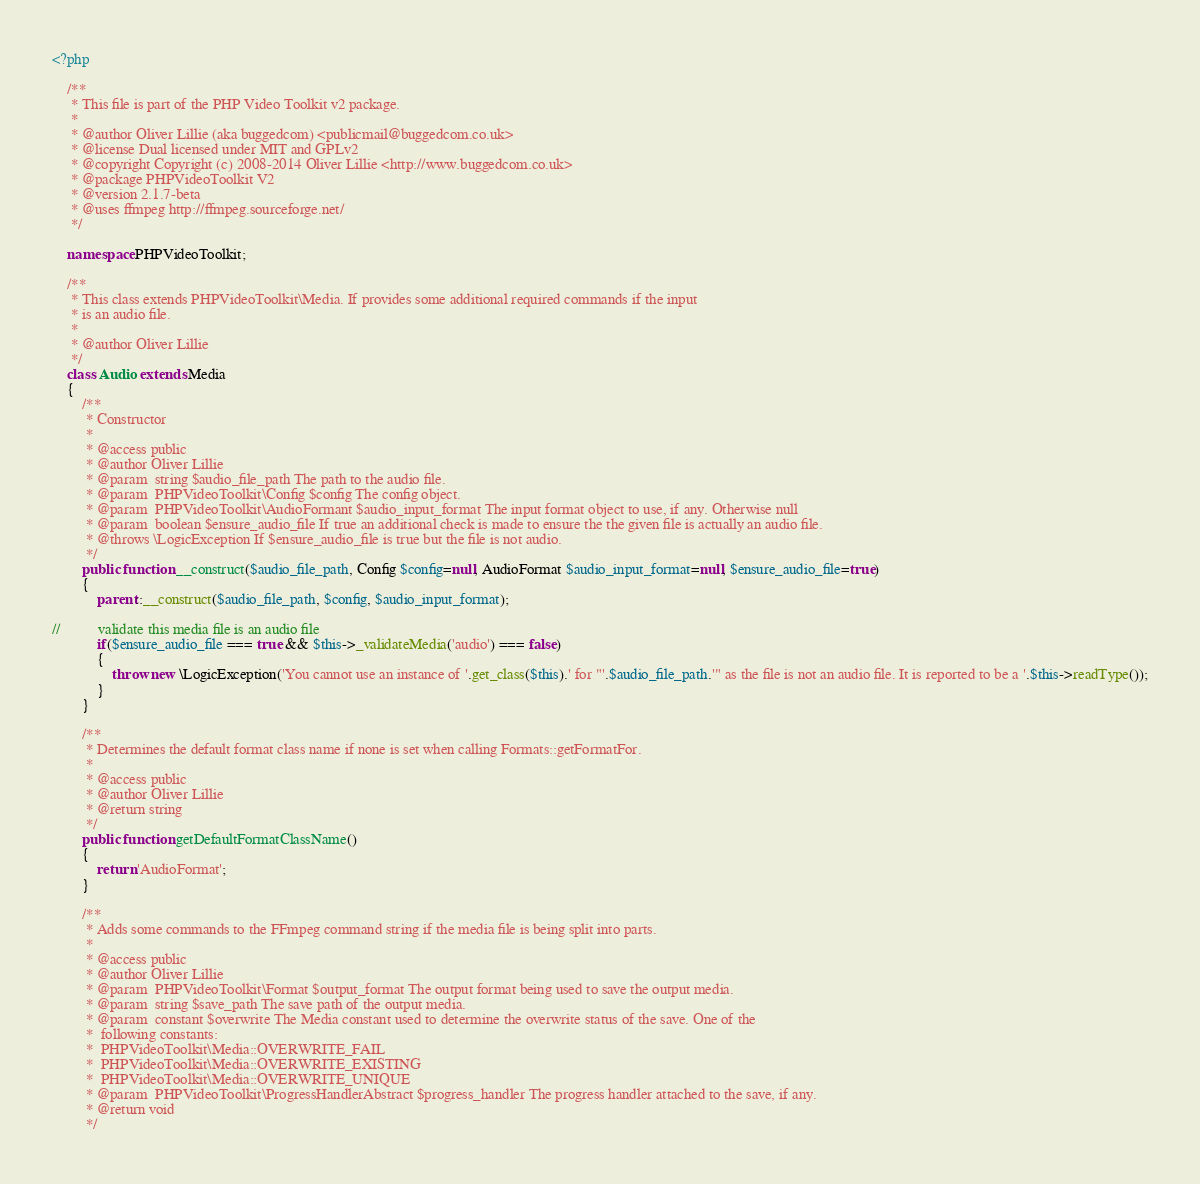Convert code to text. <code><loc_0><loc_0><loc_500><loc_500><_PHP_><?php
    
    /**
     * This file is part of the PHP Video Toolkit v2 package.
     *
     * @author Oliver Lillie (aka buggedcom) <publicmail@buggedcom.co.uk>
     * @license Dual licensed under MIT and GPLv2
     * @copyright Copyright (c) 2008-2014 Oliver Lillie <http://www.buggedcom.co.uk>
     * @package PHPVideoToolkit V2
     * @version 2.1.7-beta
     * @uses ffmpeg http://ffmpeg.sourceforge.net/
     */
     
    namespace PHPVideoToolkit;

    /**
     * This class extends PHPVideoToolkit\Media. If provides some additional required commands if the input
     * is an audio file.
     *
     * @author Oliver Lillie
     */
    class Audio extends Media
    {
        /**
         * Constructor
         *
         * @access public
         * @author Oliver Lillie
         * @param  string $audio_file_path The path to the audio file.
         * @param  PHPVideoToolkit\Config $config The config object.
         * @param  PHPVideoToolkit\AudioFormant $audio_input_format The input format object to use, if any. Otherwise null
         * @param  boolean $ensure_audio_file If true an additional check is made to ensure the the given file is actually an audio file.
         * @throws \LogicException If $ensure_audio_file is true but the file is not audio.
         */
        public function __construct($audio_file_path, Config $config=null, AudioFormat $audio_input_format=null, $ensure_audio_file=true)
        {
            parent::__construct($audio_file_path, $config, $audio_input_format);
            
//          validate this media file is an audio file
            if($ensure_audio_file === true && $this->_validateMedia('audio') === false)
            {
                throw new \LogicException('You cannot use an instance of '.get_class($this).' for "'.$audio_file_path.'" as the file is not an audio file. It is reported to be a '.$this->readType());
            }
        }
        
        /**
         * Determines the default format class name if none is set when calling Formats::getFormatFor.
         *
         * @access public
         * @author Oliver Lillie
         * @return string
         */
        public function getDefaultFormatClassName()
        {
            return 'AudioFormat';
        }
        
        /**
         * Adds some commands to the FFmpeg command string if the media file is being split into parts.
         *
         * @access public
         * @author Oliver Lillie
         * @param  PHPVideoToolkit\Format $output_format The output format being used to save the output media.
         * @param  string $save_path The save path of the output media.
         * @param  constant $overwrite The Media constant used to determine the overwrite status of the save. One of the 
         *  following constants:
         *  PHPVideoToolkit\Media::OVERWRITE_FAIL
         *  PHPVideoToolkit\Media::OVERWRITE_EXISTING
         *  PHPVideoToolkit\Media::OVERWRITE_UNIQUE
         * @param  PHPVideoToolkit\ProgressHandlerAbstract $progress_handler The progress handler attached to the save, if any. 
         * @return void
         */</code> 